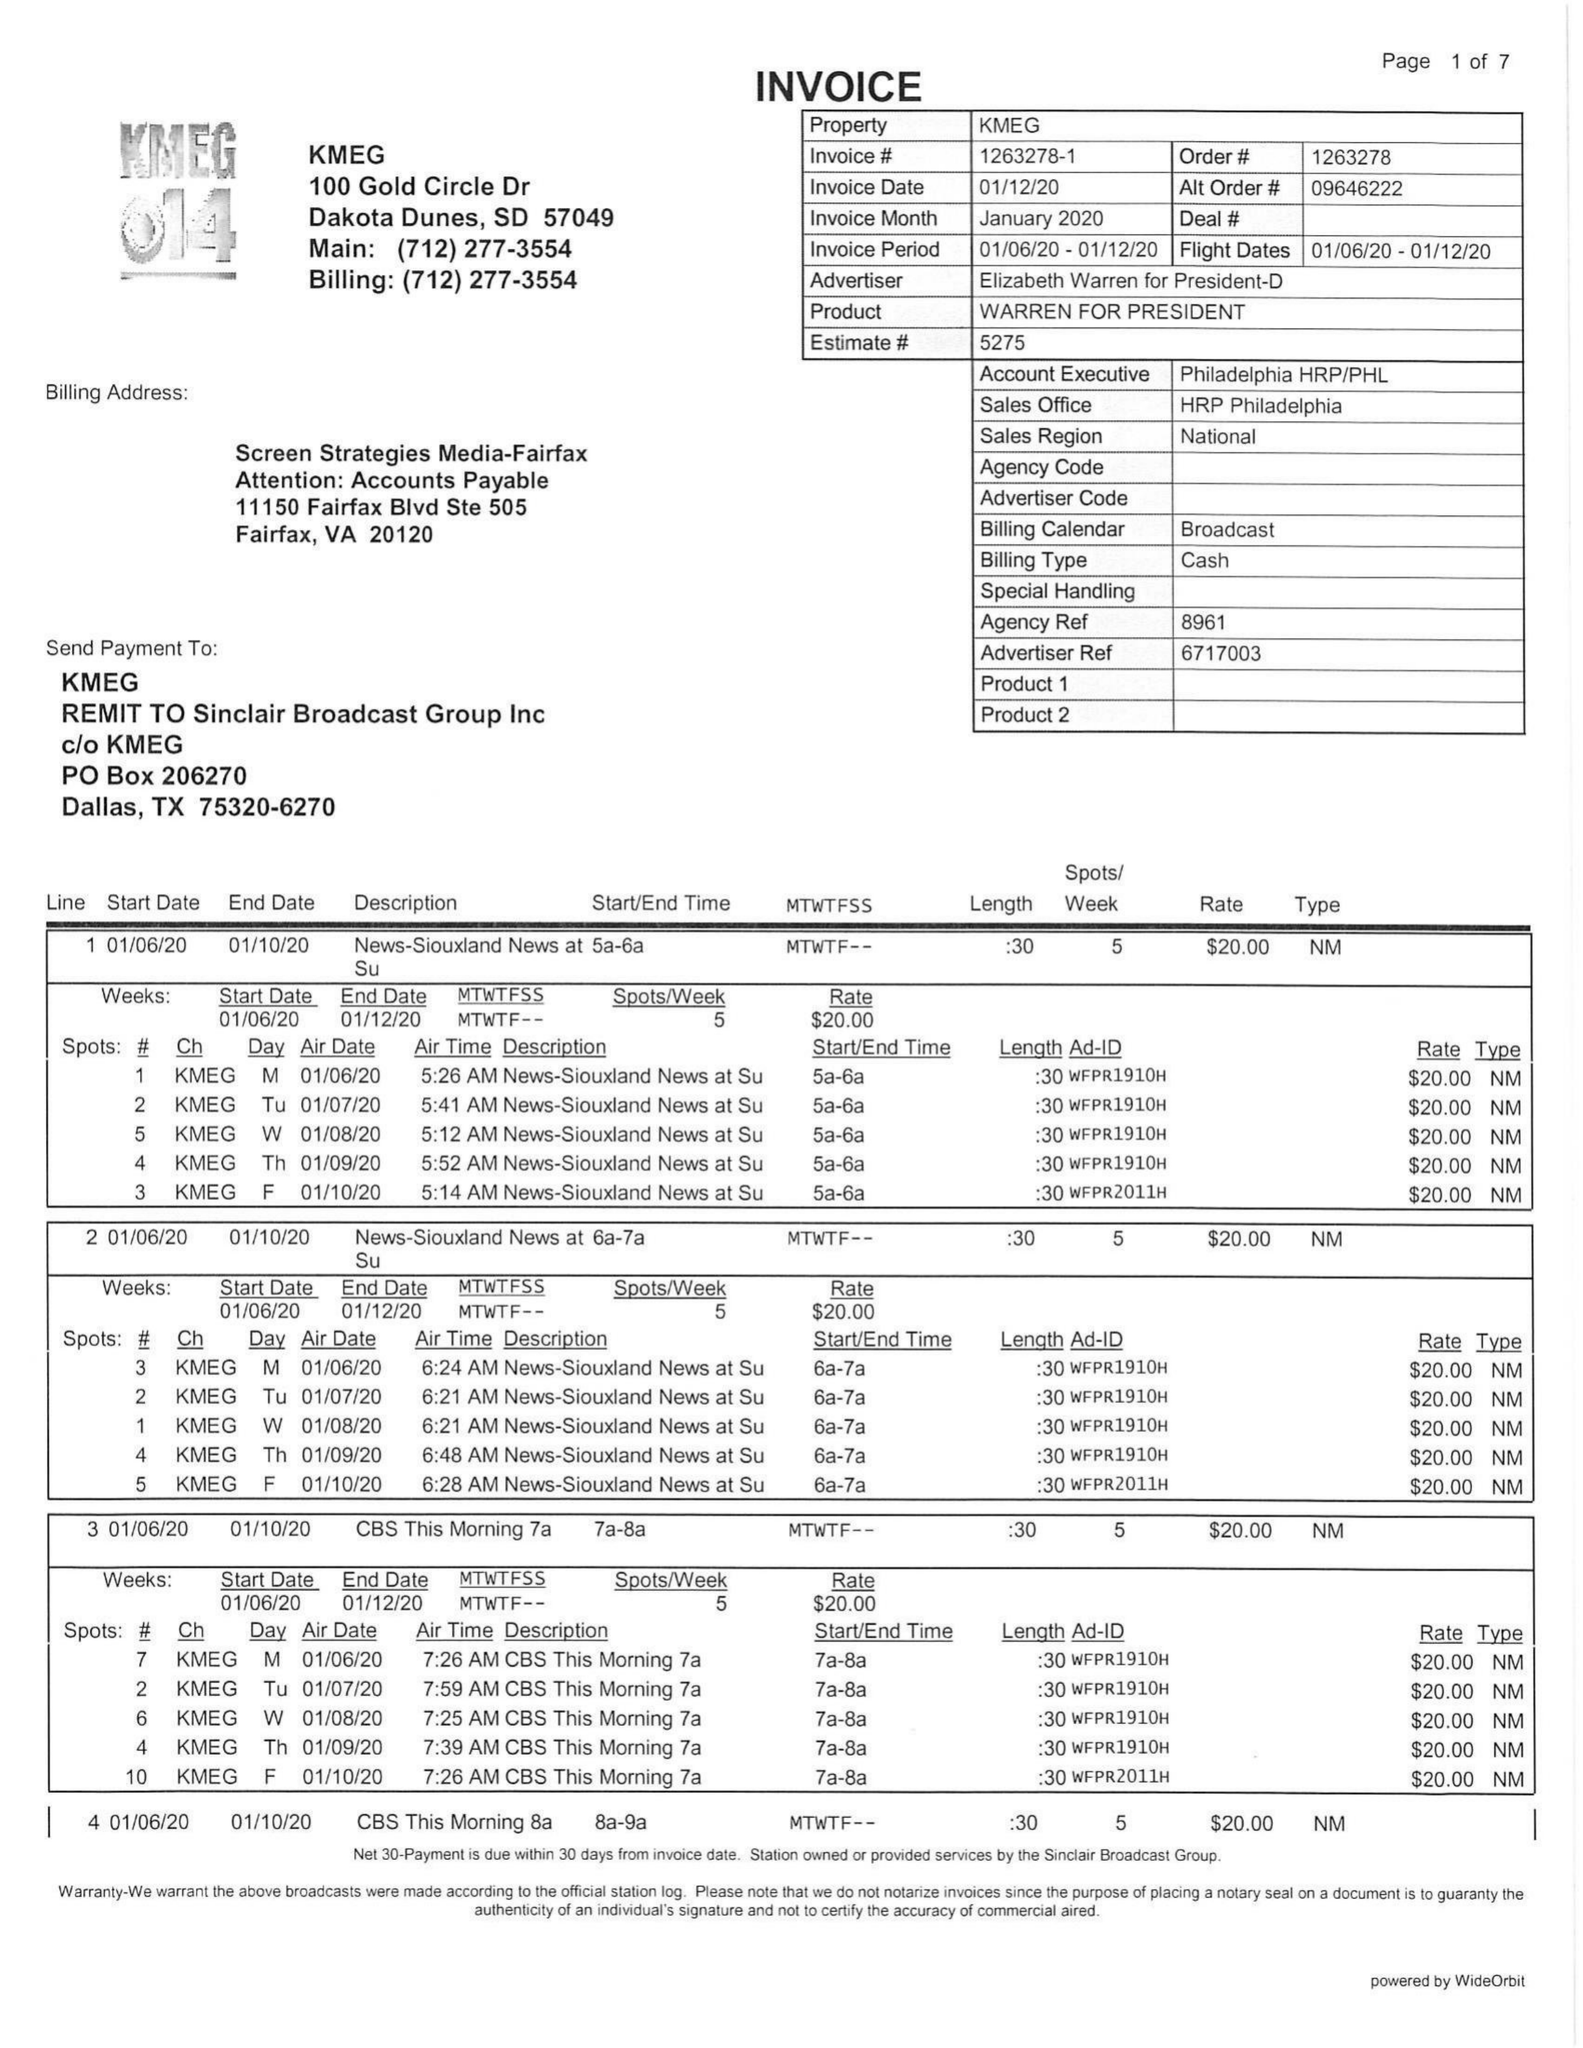What is the value for the gross_amount?
Answer the question using a single word or phrase. 6955.00 